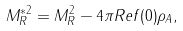Convert formula to latex. <formula><loc_0><loc_0><loc_500><loc_500>M _ { R } ^ { * 2 } = M ^ { 2 } _ { R } - 4 \pi R e { f ( 0 ) } \rho _ { A } ,</formula> 